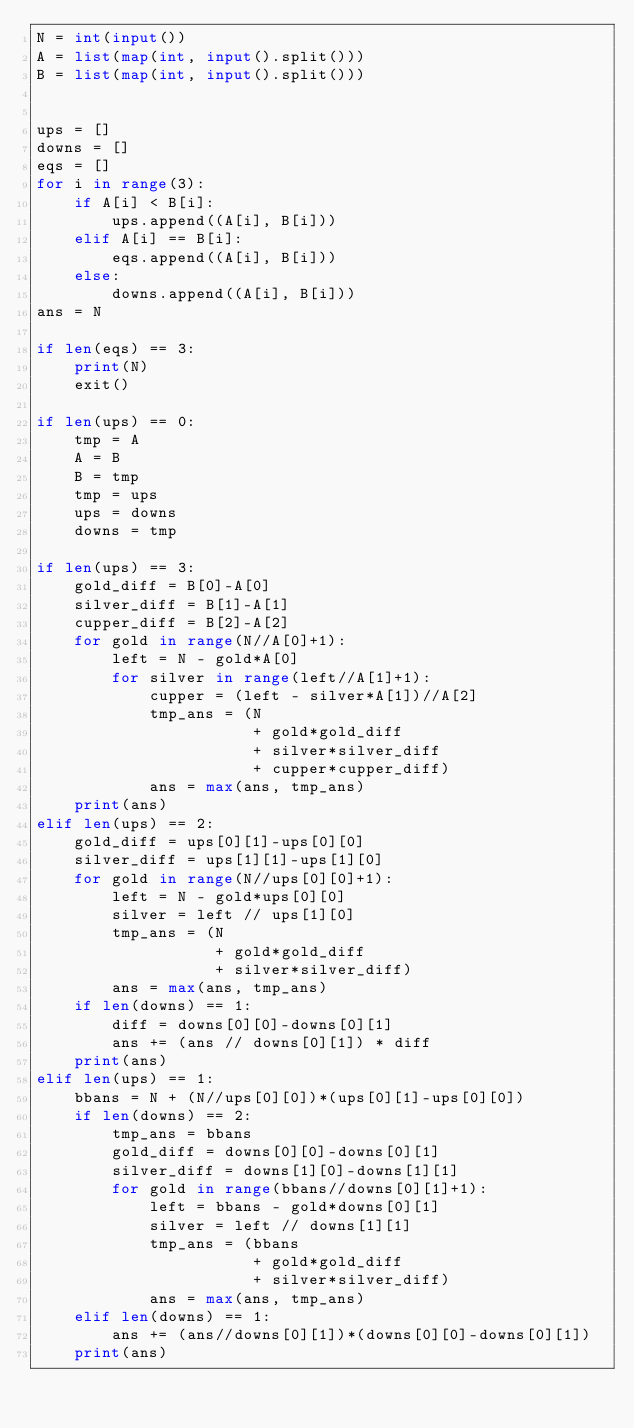<code> <loc_0><loc_0><loc_500><loc_500><_Python_>N = int(input())
A = list(map(int, input().split()))
B = list(map(int, input().split()))


ups = []
downs = []
eqs = []
for i in range(3):
    if A[i] < B[i]:
        ups.append((A[i], B[i]))
    elif A[i] == B[i]:
        eqs.append((A[i], B[i]))
    else:
        downs.append((A[i], B[i]))
ans = N

if len(eqs) == 3:
    print(N)
    exit()

if len(ups) == 0:
    tmp = A
    A = B
    B = tmp
    tmp = ups
    ups = downs
    downs = tmp

if len(ups) == 3:
    gold_diff = B[0]-A[0]
    silver_diff = B[1]-A[1]
    cupper_diff = B[2]-A[2]
    for gold in range(N//A[0]+1):
        left = N - gold*A[0]
        for silver in range(left//A[1]+1):
            cupper = (left - silver*A[1])//A[2]
            tmp_ans = (N
                       + gold*gold_diff
                       + silver*silver_diff
                       + cupper*cupper_diff)
            ans = max(ans, tmp_ans)
    print(ans)
elif len(ups) == 2:
    gold_diff = ups[0][1]-ups[0][0]
    silver_diff = ups[1][1]-ups[1][0]
    for gold in range(N//ups[0][0]+1):
        left = N - gold*ups[0][0]
        silver = left // ups[1][0]
        tmp_ans = (N
                   + gold*gold_diff
                   + silver*silver_diff)
        ans = max(ans, tmp_ans)
    if len(downs) == 1:
        diff = downs[0][0]-downs[0][1]
        ans += (ans // downs[0][1]) * diff
    print(ans)
elif len(ups) == 1:
    bbans = N + (N//ups[0][0])*(ups[0][1]-ups[0][0])
    if len(downs) == 2:
        tmp_ans = bbans
        gold_diff = downs[0][0]-downs[0][1]
        silver_diff = downs[1][0]-downs[1][1]
        for gold in range(bbans//downs[0][1]+1):
            left = bbans - gold*downs[0][1]
            silver = left // downs[1][1]
            tmp_ans = (bbans
                       + gold*gold_diff
                       + silver*silver_diff)
            ans = max(ans, tmp_ans)
    elif len(downs) == 1:
        ans += (ans//downs[0][1])*(downs[0][0]-downs[0][1])
    print(ans)
</code> 